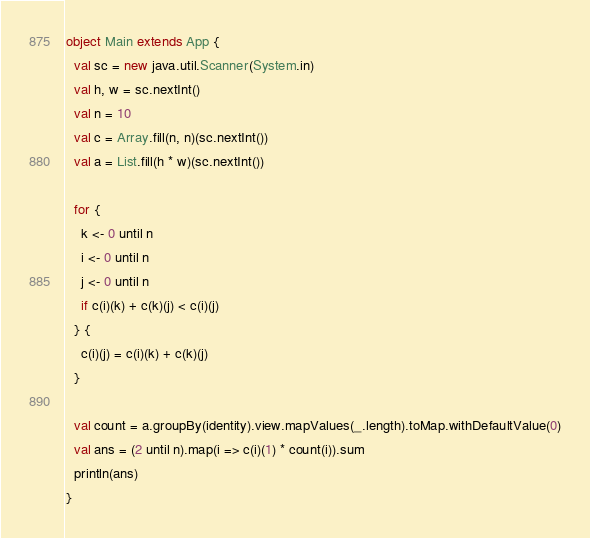<code> <loc_0><loc_0><loc_500><loc_500><_Scala_>object Main extends App {
  val sc = new java.util.Scanner(System.in)
  val h, w = sc.nextInt()
  val n = 10
  val c = Array.fill(n, n)(sc.nextInt())
  val a = List.fill(h * w)(sc.nextInt())

  for {
    k <- 0 until n
    i <- 0 until n
    j <- 0 until n
    if c(i)(k) + c(k)(j) < c(i)(j)
  } {
    c(i)(j) = c(i)(k) + c(k)(j)
  }

  val count = a.groupBy(identity).view.mapValues(_.length).toMap.withDefaultValue(0)
  val ans = (2 until n).map(i => c(i)(1) * count(i)).sum
  println(ans)
}
</code> 